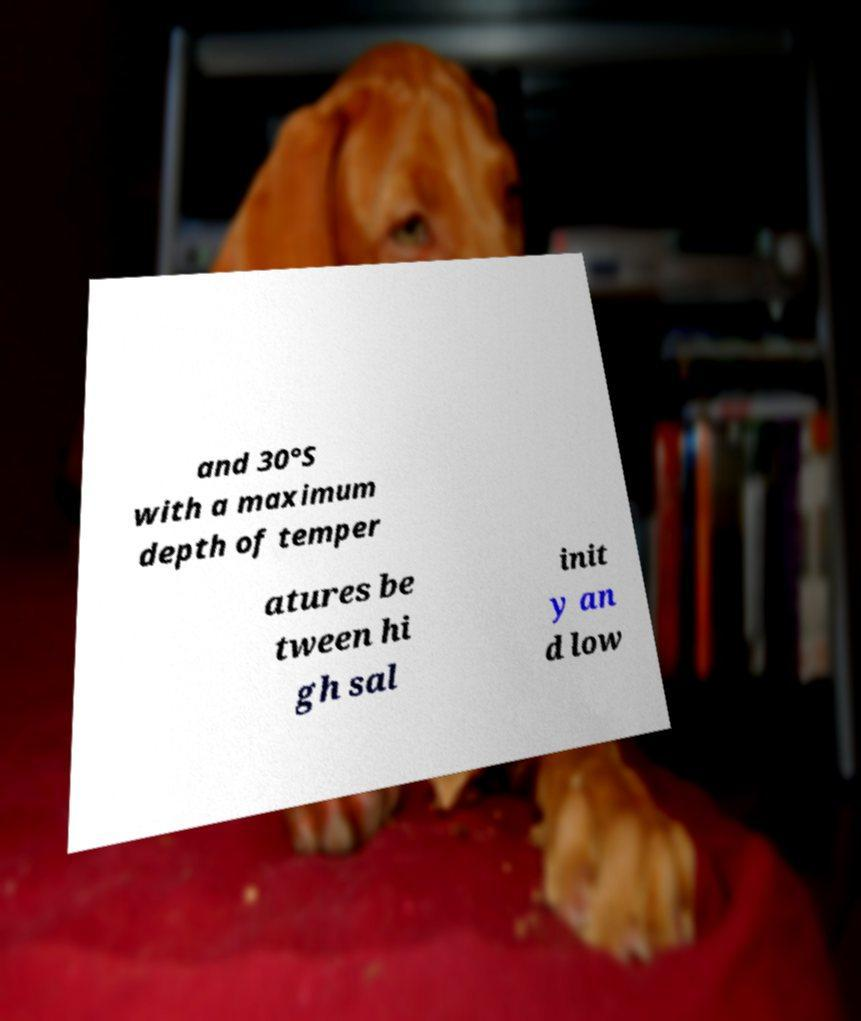What messages or text are displayed in this image? I need them in a readable, typed format. and 30°S with a maximum depth of temper atures be tween hi gh sal init y an d low 